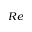<formula> <loc_0><loc_0><loc_500><loc_500>R e</formula> 